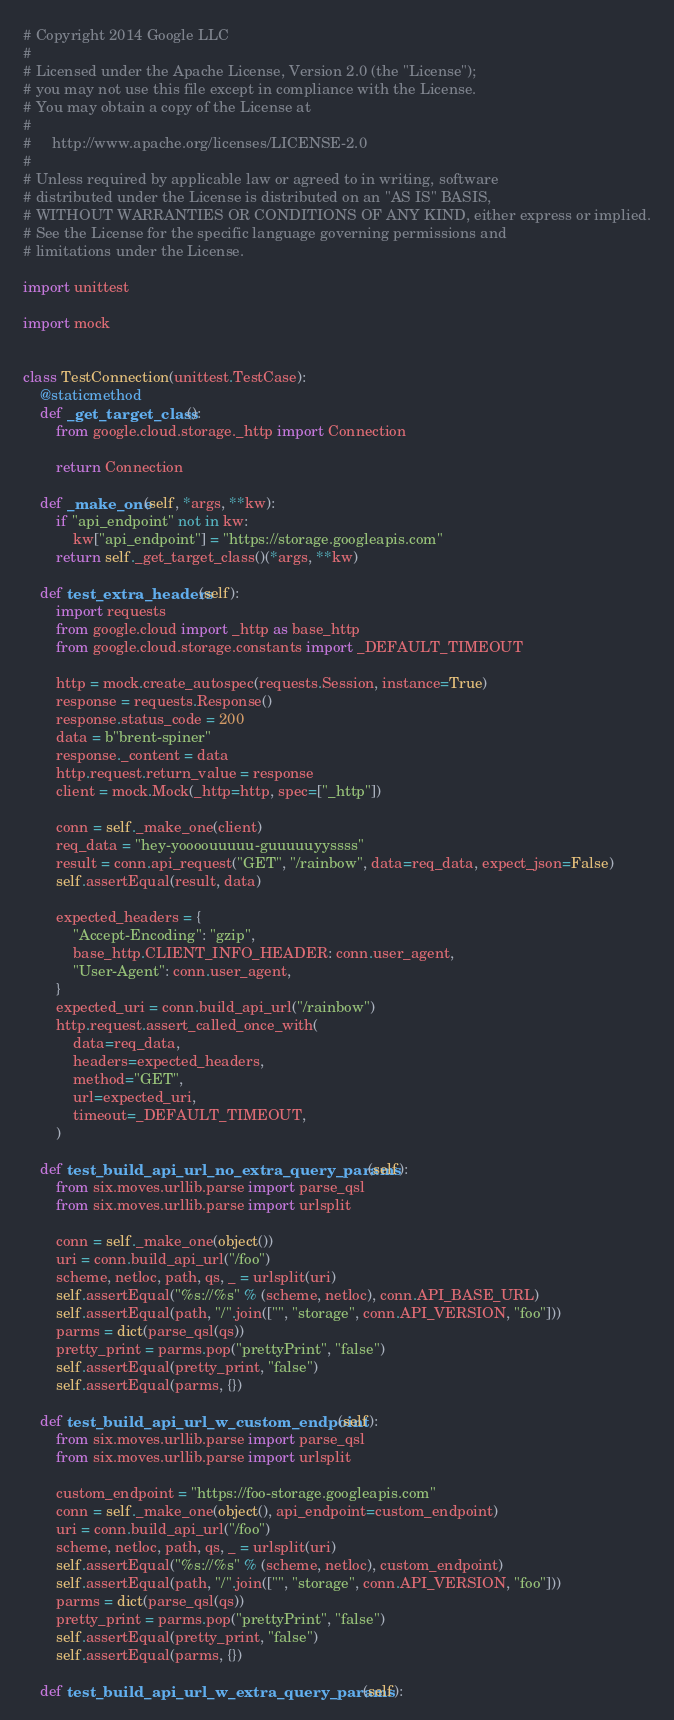<code> <loc_0><loc_0><loc_500><loc_500><_Python_># Copyright 2014 Google LLC
#
# Licensed under the Apache License, Version 2.0 (the "License");
# you may not use this file except in compliance with the License.
# You may obtain a copy of the License at
#
#     http://www.apache.org/licenses/LICENSE-2.0
#
# Unless required by applicable law or agreed to in writing, software
# distributed under the License is distributed on an "AS IS" BASIS,
# WITHOUT WARRANTIES OR CONDITIONS OF ANY KIND, either express or implied.
# See the License for the specific language governing permissions and
# limitations under the License.

import unittest

import mock


class TestConnection(unittest.TestCase):
    @staticmethod
    def _get_target_class():
        from google.cloud.storage._http import Connection

        return Connection

    def _make_one(self, *args, **kw):
        if "api_endpoint" not in kw:
            kw["api_endpoint"] = "https://storage.googleapis.com"
        return self._get_target_class()(*args, **kw)

    def test_extra_headers(self):
        import requests
        from google.cloud import _http as base_http
        from google.cloud.storage.constants import _DEFAULT_TIMEOUT

        http = mock.create_autospec(requests.Session, instance=True)
        response = requests.Response()
        response.status_code = 200
        data = b"brent-spiner"
        response._content = data
        http.request.return_value = response
        client = mock.Mock(_http=http, spec=["_http"])

        conn = self._make_one(client)
        req_data = "hey-yoooouuuuu-guuuuuyyssss"
        result = conn.api_request("GET", "/rainbow", data=req_data, expect_json=False)
        self.assertEqual(result, data)

        expected_headers = {
            "Accept-Encoding": "gzip",
            base_http.CLIENT_INFO_HEADER: conn.user_agent,
            "User-Agent": conn.user_agent,
        }
        expected_uri = conn.build_api_url("/rainbow")
        http.request.assert_called_once_with(
            data=req_data,
            headers=expected_headers,
            method="GET",
            url=expected_uri,
            timeout=_DEFAULT_TIMEOUT,
        )

    def test_build_api_url_no_extra_query_params(self):
        from six.moves.urllib.parse import parse_qsl
        from six.moves.urllib.parse import urlsplit

        conn = self._make_one(object())
        uri = conn.build_api_url("/foo")
        scheme, netloc, path, qs, _ = urlsplit(uri)
        self.assertEqual("%s://%s" % (scheme, netloc), conn.API_BASE_URL)
        self.assertEqual(path, "/".join(["", "storage", conn.API_VERSION, "foo"]))
        parms = dict(parse_qsl(qs))
        pretty_print = parms.pop("prettyPrint", "false")
        self.assertEqual(pretty_print, "false")
        self.assertEqual(parms, {})

    def test_build_api_url_w_custom_endpoint(self):
        from six.moves.urllib.parse import parse_qsl
        from six.moves.urllib.parse import urlsplit

        custom_endpoint = "https://foo-storage.googleapis.com"
        conn = self._make_one(object(), api_endpoint=custom_endpoint)
        uri = conn.build_api_url("/foo")
        scheme, netloc, path, qs, _ = urlsplit(uri)
        self.assertEqual("%s://%s" % (scheme, netloc), custom_endpoint)
        self.assertEqual(path, "/".join(["", "storage", conn.API_VERSION, "foo"]))
        parms = dict(parse_qsl(qs))
        pretty_print = parms.pop("prettyPrint", "false")
        self.assertEqual(pretty_print, "false")
        self.assertEqual(parms, {})

    def test_build_api_url_w_extra_query_params(self):</code> 